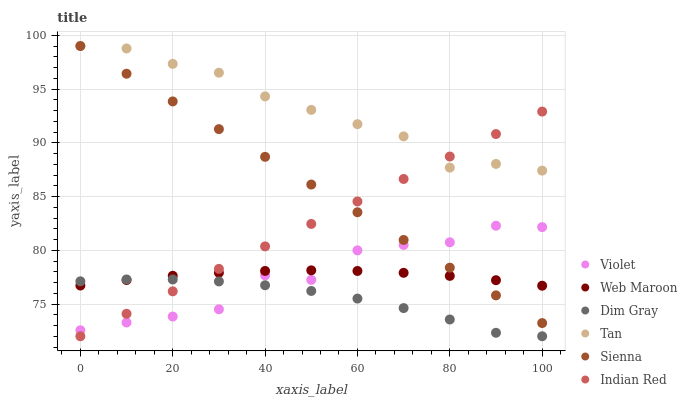Does Dim Gray have the minimum area under the curve?
Answer yes or no. Yes. Does Tan have the maximum area under the curve?
Answer yes or no. Yes. Does Web Maroon have the minimum area under the curve?
Answer yes or no. No. Does Web Maroon have the maximum area under the curve?
Answer yes or no. No. Is Indian Red the smoothest?
Answer yes or no. Yes. Is Violet the roughest?
Answer yes or no. Yes. Is Web Maroon the smoothest?
Answer yes or no. No. Is Web Maroon the roughest?
Answer yes or no. No. Does Dim Gray have the lowest value?
Answer yes or no. Yes. Does Web Maroon have the lowest value?
Answer yes or no. No. Does Tan have the highest value?
Answer yes or no. Yes. Does Web Maroon have the highest value?
Answer yes or no. No. Is Web Maroon less than Tan?
Answer yes or no. Yes. Is Tan greater than Dim Gray?
Answer yes or no. Yes. Does Indian Red intersect Sienna?
Answer yes or no. Yes. Is Indian Red less than Sienna?
Answer yes or no. No. Is Indian Red greater than Sienna?
Answer yes or no. No. Does Web Maroon intersect Tan?
Answer yes or no. No. 